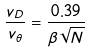<formula> <loc_0><loc_0><loc_500><loc_500>\frac { v _ { D } } { v _ { \theta } } = \frac { 0 . 3 9 } { \beta \sqrt { N } }</formula> 